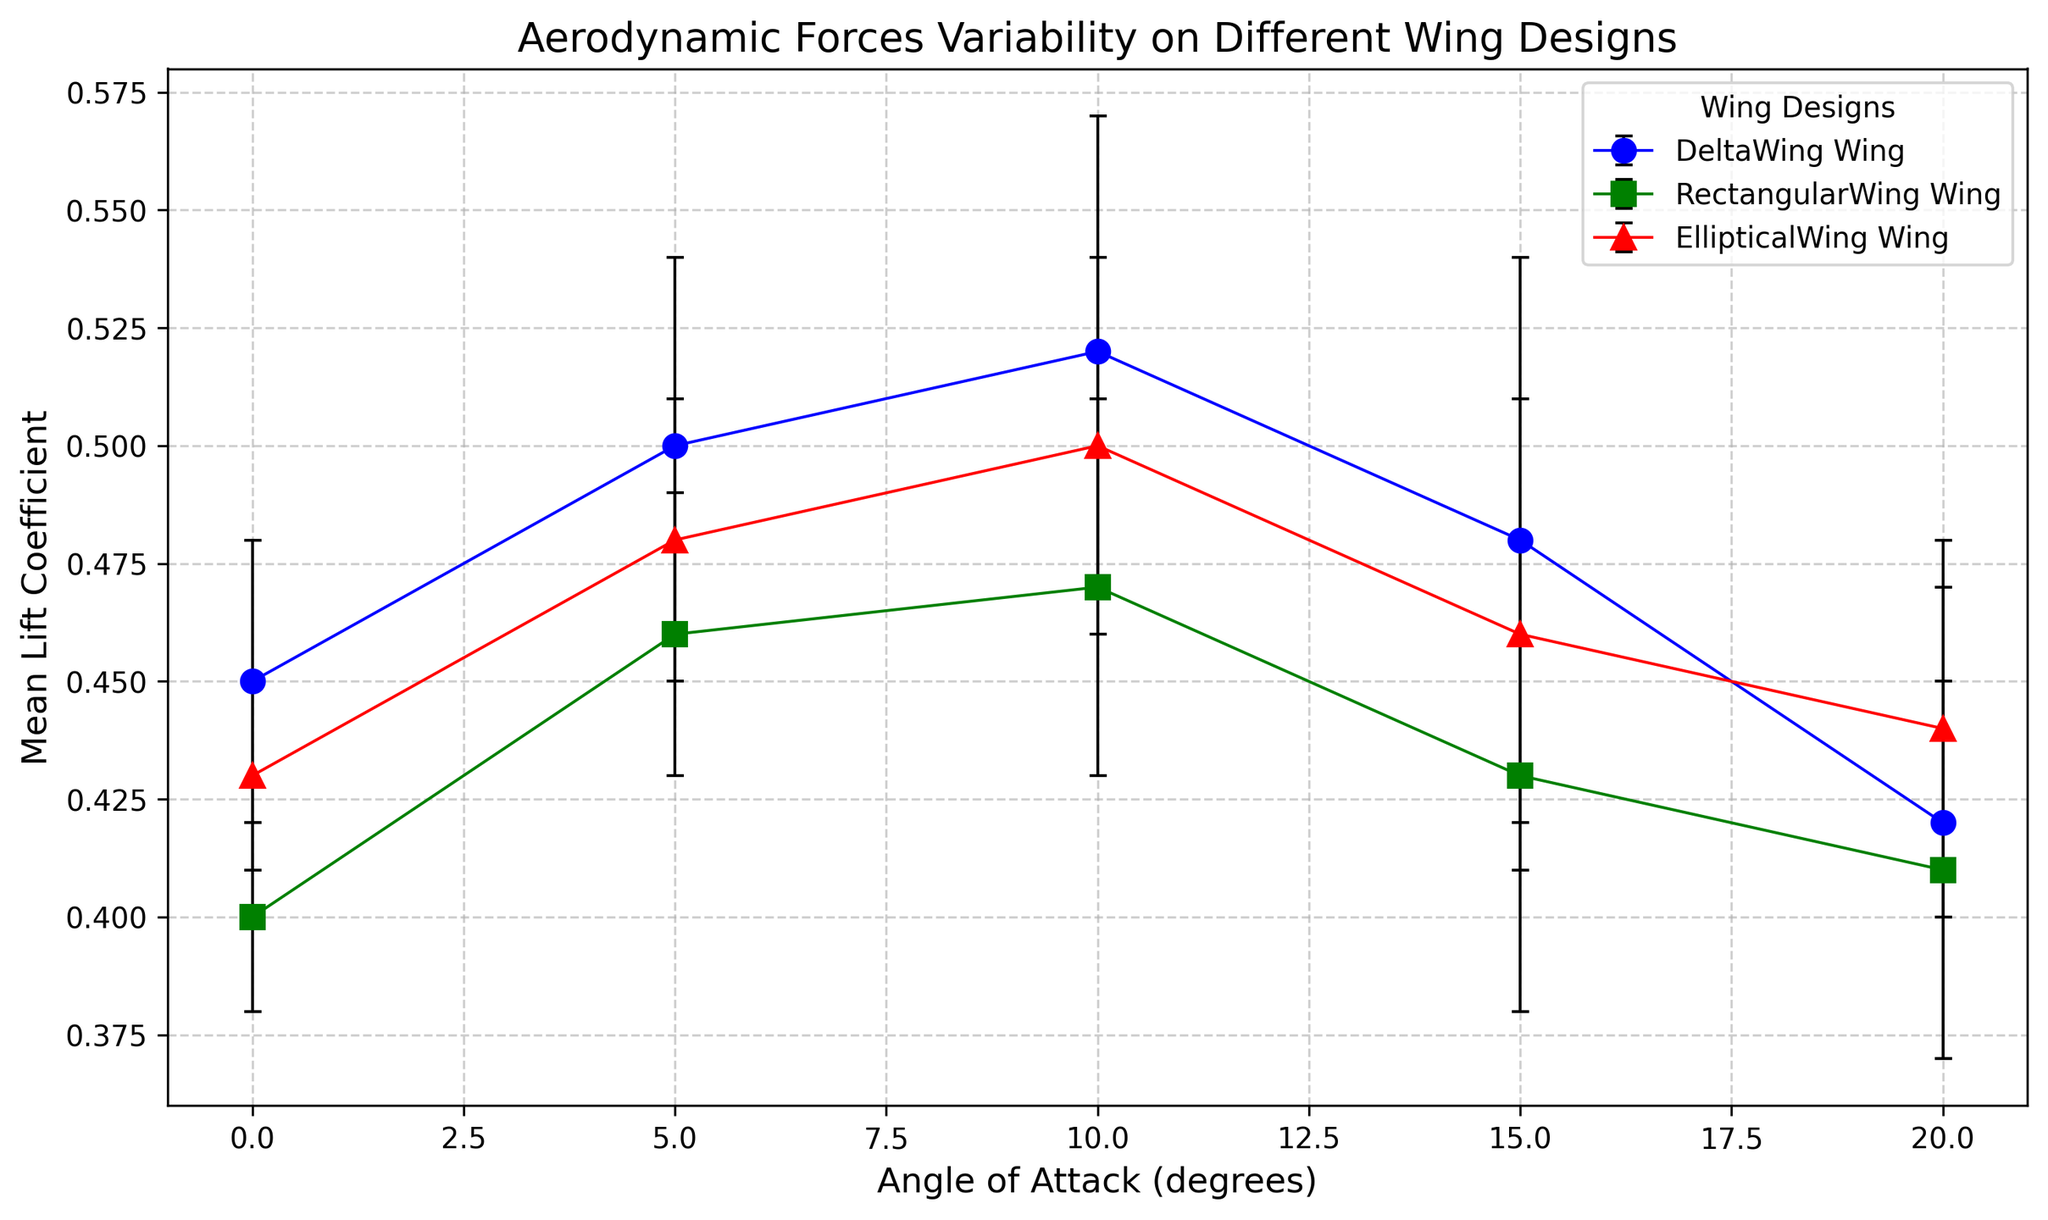How does the mean lift coefficient of the Delta Wing at 10 degrees angle of attack compare to that of the Rectangular Wing at the same angle? First, identify the mean lift coefficients for both wings at 10 degrees from the plot. For the Delta Wing, it's around 0.52. For the Rectangular Wing, it's around 0.47. Thus, the Delta Wing has a higher mean lift coefficient at 10 degrees compared to the Rectangular Wing.
Answer: The Delta Wing has a higher mean lift coefficient Which wing design shows the smallest variation in lift coefficient at 20 degrees angle of attack? Look at the error bars (representing standard deviation) for each wing design at 20 degrees on the plot. The Rectangular Wing has the smallest error bar at 20 degrees compared to the Delta Wing and Elliptical Wing.
Answer: Rectangular Wing At what angle of attack does the Elliptical Wing achieve its highest mean lift coefficient? Locate the points for the Elliptical Wing on the plot and identify which angle of attack corresponds to the highest mean lift coefficient. The Elliptical Wing achieves its highest mean lift coefficient at 10 degrees angle of attack.
Answer: 10 degrees Which wing design experiences a decrease in mean lift coefficient as the angle of attack increases from 10 to 15 degrees? Observe the trend in mean lift coefficients between 10 and 15 degrees for each wing design. The Delta Wing's mean lift coefficient decreases from 0.52 at 10 degrees to 0.48 at 15 degrees.
Answer: Delta Wing What is the average mean lift coefficient of the Rectangular Wing across all angles of attack? Calculate the mean lift coefficient of the Rectangular Wing at each angle (0, 5, 10, 15, 20), sum them up (0.40 + 0.46 + 0.47 + 0.43 + 0.41 = 2.17), and then divide by the number of angles (5). The average is 2.17 / 5 = 0.434.
Answer: 0.434 By how much does the mean lift coefficient of the Delta Wing change from 0 to 20 degrees angle of attack? Determine the mean lift coefficients at 0 degrees (0.45) and 20 degrees (0.42) for the Delta Wing. The change is 0.45 - 0.42 = 0.03.
Answer: 0.03 Comparing all wing designs, which one consistently has the highest mean lift coefficient across the initial three angles of attack (0 to 10 degrees)? Look at the mean lift coefficients for each wing design at 0, 5, and 10 degrees. The Delta Wing has 0.45, 0.50, and 0.52 respectively, which are higher than the other designs.
Answer: Delta Wing 